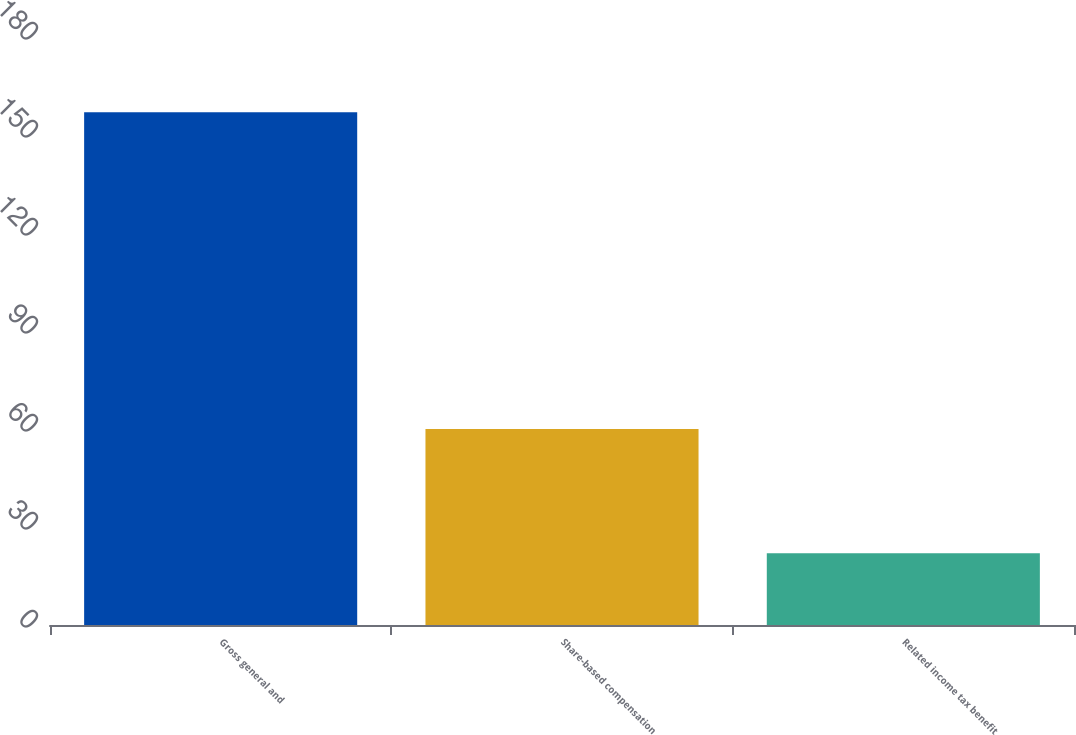Convert chart. <chart><loc_0><loc_0><loc_500><loc_500><bar_chart><fcel>Gross general and<fcel>Share-based compensation<fcel>Related income tax benefit<nl><fcel>157<fcel>60<fcel>22<nl></chart> 